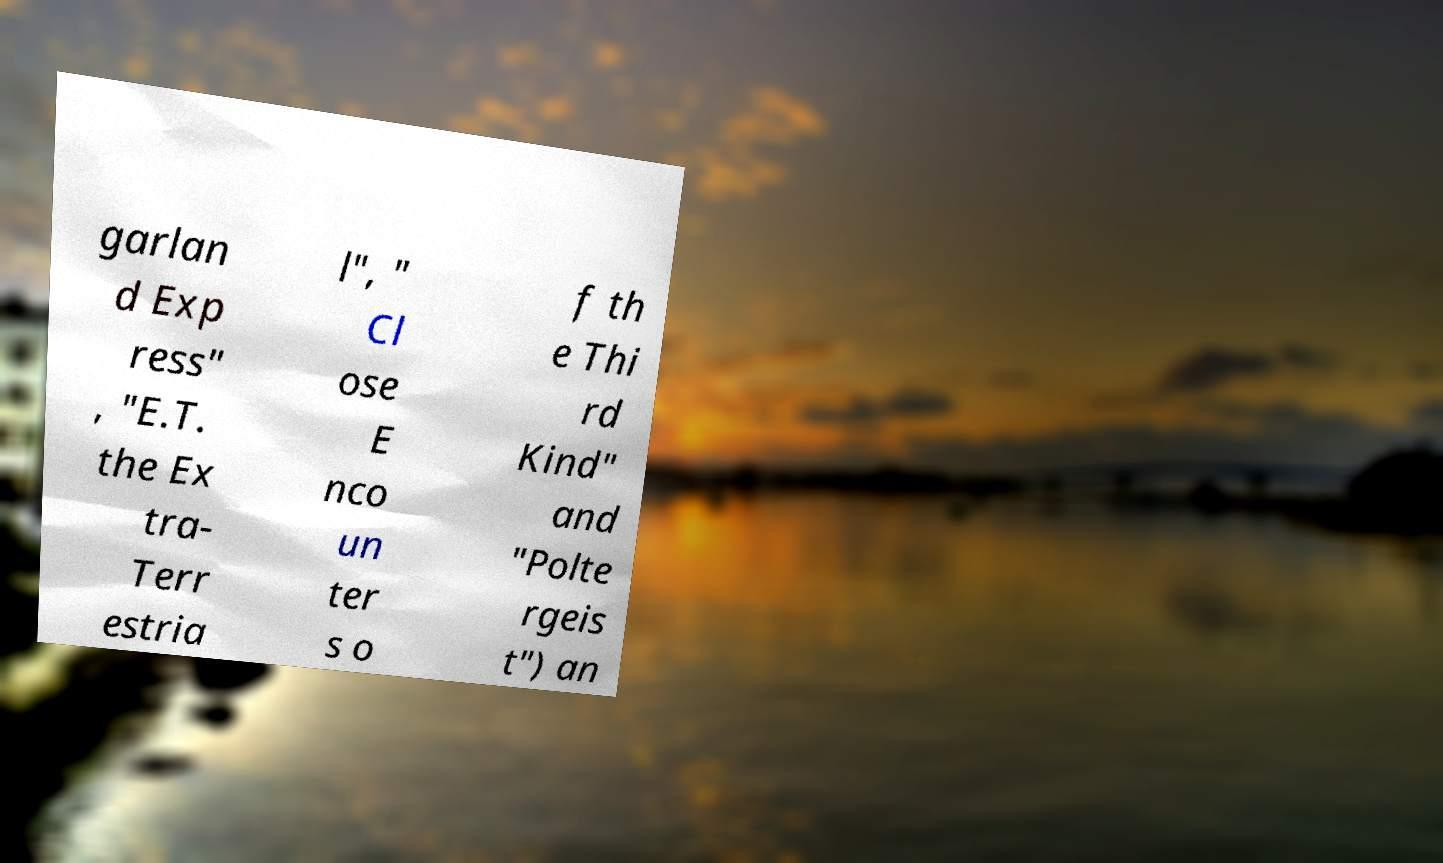Could you extract and type out the text from this image? garlan d Exp ress" , "E.T. the Ex tra- Terr estria l", " Cl ose E nco un ter s o f th e Thi rd Kind" and "Polte rgeis t") an 